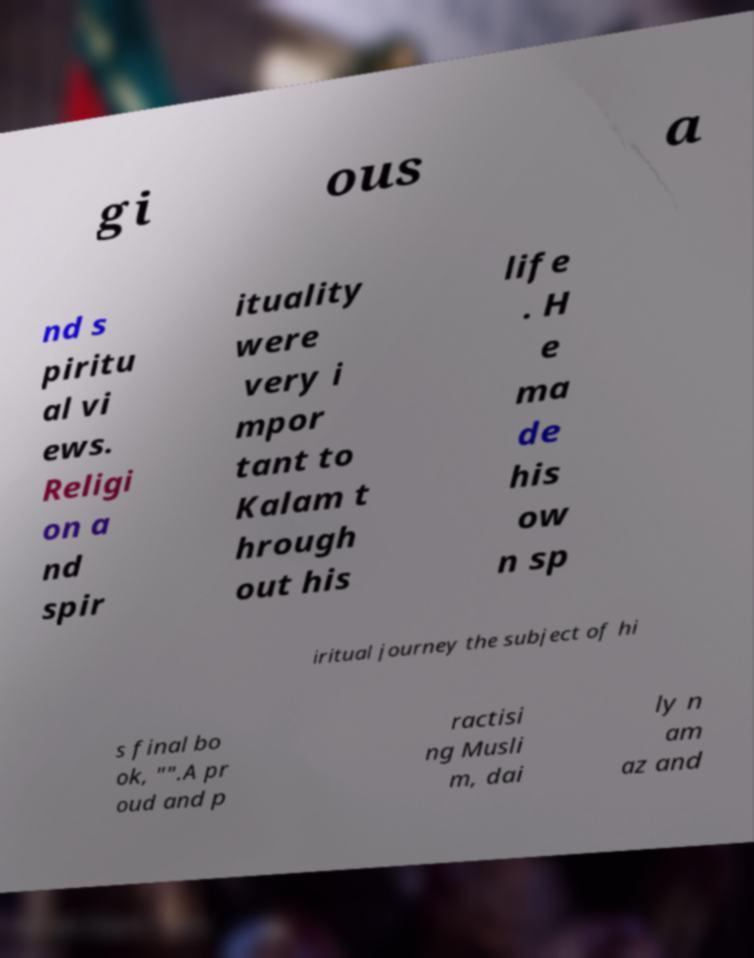Can you read and provide the text displayed in the image?This photo seems to have some interesting text. Can you extract and type it out for me? gi ous a nd s piritu al vi ews. Religi on a nd spir ituality were very i mpor tant to Kalam t hrough out his life . H e ma de his ow n sp iritual journey the subject of hi s final bo ok, "".A pr oud and p ractisi ng Musli m, dai ly n am az and 